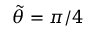<formula> <loc_0><loc_0><loc_500><loc_500>\tilde { \theta } = \pi / 4</formula> 